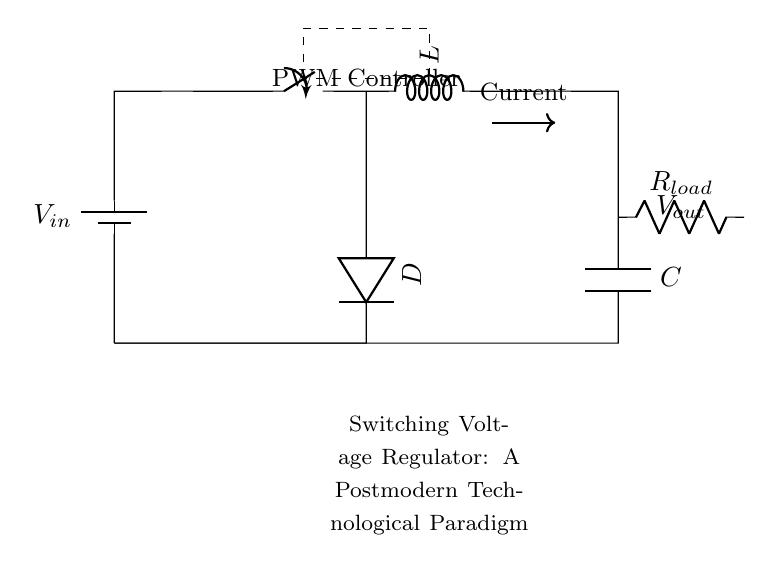What is the input voltage of this circuit? The input voltage is represented by the source labeled V in the circuit. It is depicted as a battery symbol, indicating the voltage supply to the regulator.
Answer: V in What component is used for energy storage in this regulator? The energy storage component in this circuit is the inductor, labeled as L. It typically stores energy in the magnetic field when current flows through it.
Answer: L What is the purpose of the switch in this circuit? The switch controls the flow of current to the inductor. When it is open, the inductor does not receive energy; when closed, it allows current to flow, which initiates the energy transfer process.
Answer: Current control How does the PWM controller affect the output voltage? The PWM (Pulse Width Modulation) controller adjusts the duty cycle, meaning it changes the ratio of 'on' time to 'off' time of the switch. This modulation influences the average voltage delivered to the load.
Answer: Output voltage adjustment What role does the diode play in this circuit? The diode, labeled as D, allows current to flow in only one direction, preventing backflow when the switch is opened. This ensures that energy stored in the inductor is delivered to the output efficiently.
Answer: Prevents backflow What is connected to the output of this regulator? The load is connected at the output, labeled as R load. This component represents the device or circuit that receives the regulated voltage and current from the regulator.
Answer: R load What is the output voltage of this circuit? The output voltage is denoted as V out. It is the voltage delivered to the load after regulation, influenced by the inductor and PWM controller's adjustments.
Answer: V out 